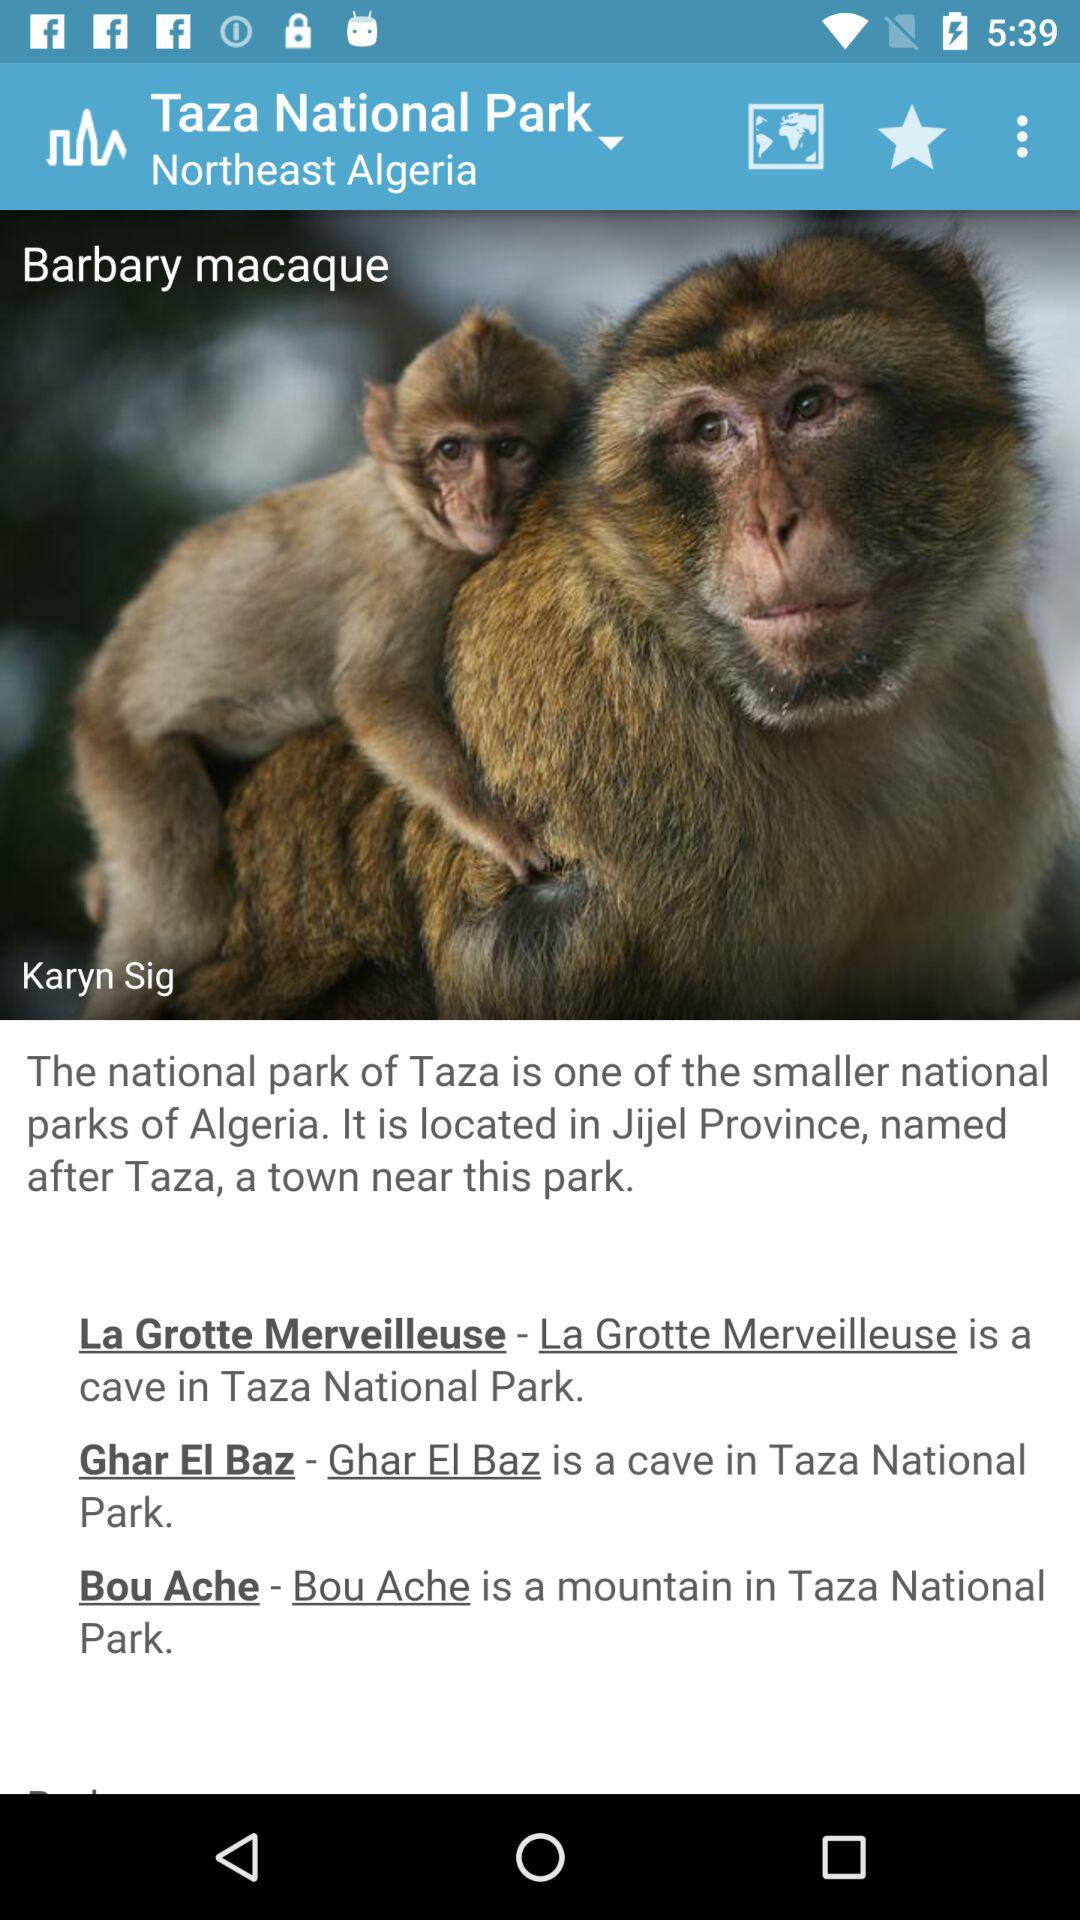Where is the national park located? The national park is located in Jijel Province. 